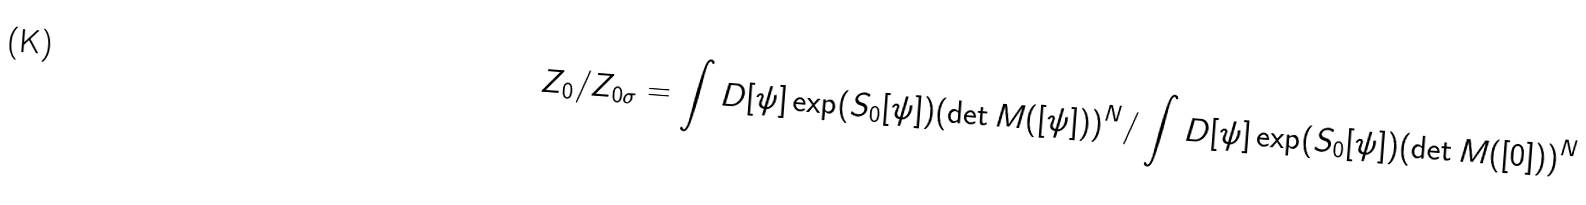Convert formula to latex. <formula><loc_0><loc_0><loc_500><loc_500>Z _ { 0 } / Z _ { 0 \sigma } = \int D [ \psi ] \exp ( S _ { 0 } [ \psi ] ) ( \det M ( [ \psi ] ) ) ^ { N } / \int D [ \psi ] \exp ( S _ { 0 } [ \psi ] ) ( \det M ( [ 0 ] ) ) ^ { N }</formula> 